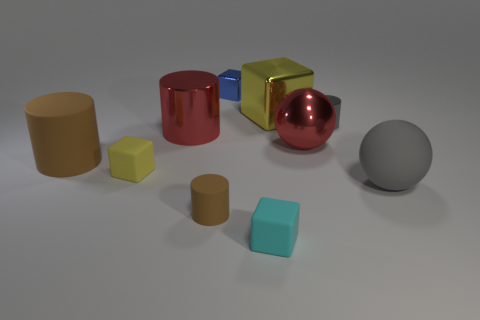Subtract all yellow cubes. How many were subtracted if there are1yellow cubes left? 1 Subtract 1 cylinders. How many cylinders are left? 3 Subtract all spheres. How many objects are left? 8 Add 3 blue cubes. How many blue cubes are left? 4 Add 6 tiny purple balls. How many tiny purple balls exist? 6 Subtract 1 yellow blocks. How many objects are left? 9 Subtract all big gray matte objects. Subtract all large green shiny things. How many objects are left? 9 